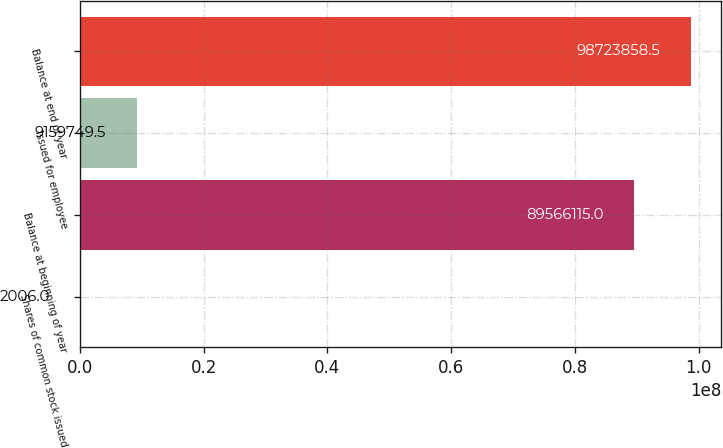Convert chart to OTSL. <chart><loc_0><loc_0><loc_500><loc_500><bar_chart><fcel>Shares of common stock issued<fcel>Balance at beginning of year<fcel>Issued for employee<fcel>Balance at end of year<nl><fcel>2006<fcel>8.95661e+07<fcel>9.15975e+06<fcel>9.87239e+07<nl></chart> 